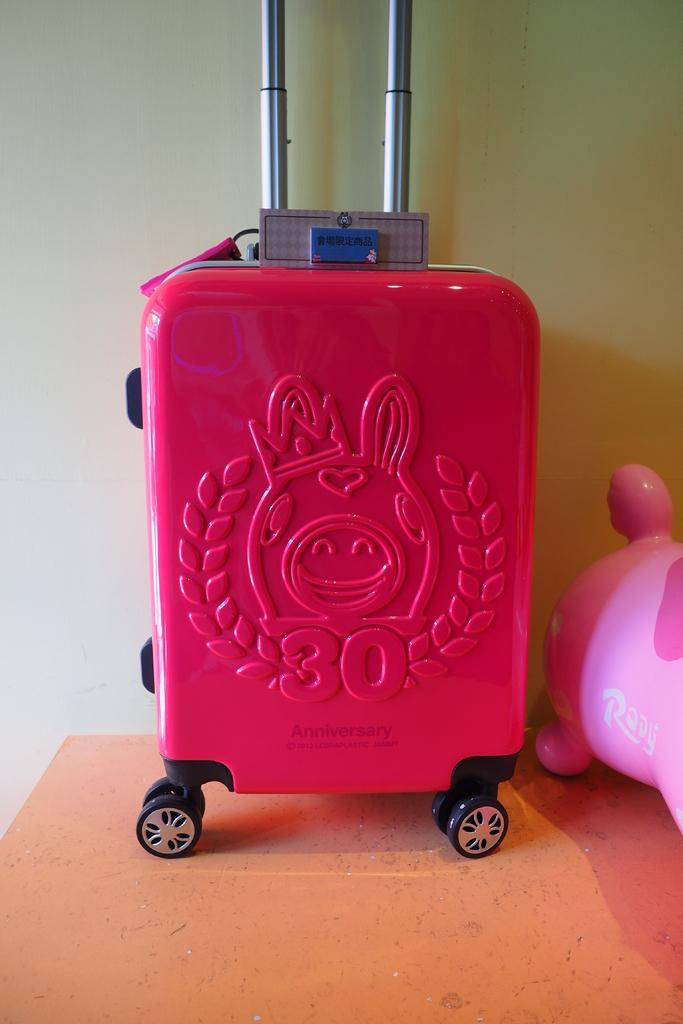What is the color of the bag that is visible in the image? There is a red color bag in the image. Can you see a toad hopping out of the red color bag in the image? There is no toad present in the image, and the bag does not show any signs of a toad hopping out of it. 